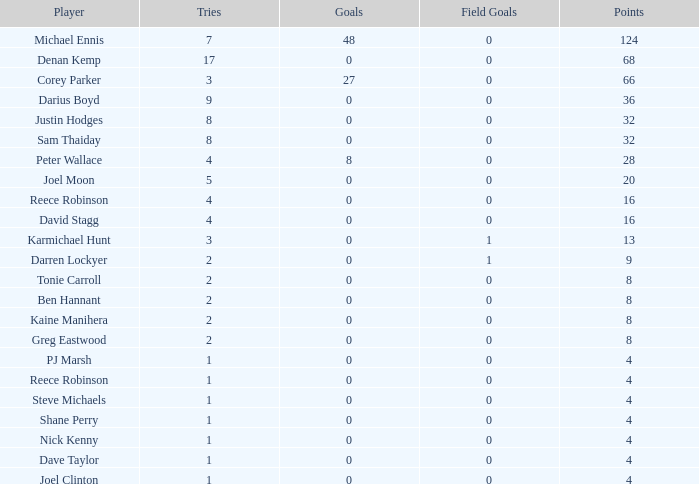What is the lowest tries the player with more than 0 goals, 28 points, and more than 0 field goals have? None. 